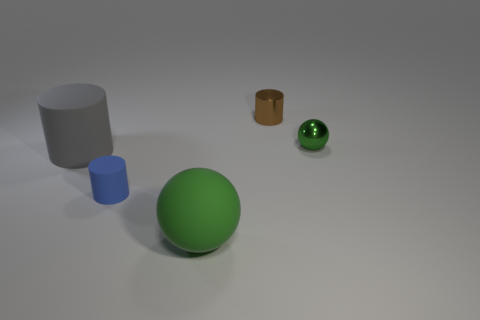Add 3 blue rubber cylinders. How many objects exist? 8 Subtract all balls. How many objects are left? 3 Subtract all green balls. Subtract all big brown shiny cylinders. How many objects are left? 3 Add 3 rubber objects. How many rubber objects are left? 6 Add 3 large cyan metallic cylinders. How many large cyan metallic cylinders exist? 3 Subtract 0 purple balls. How many objects are left? 5 